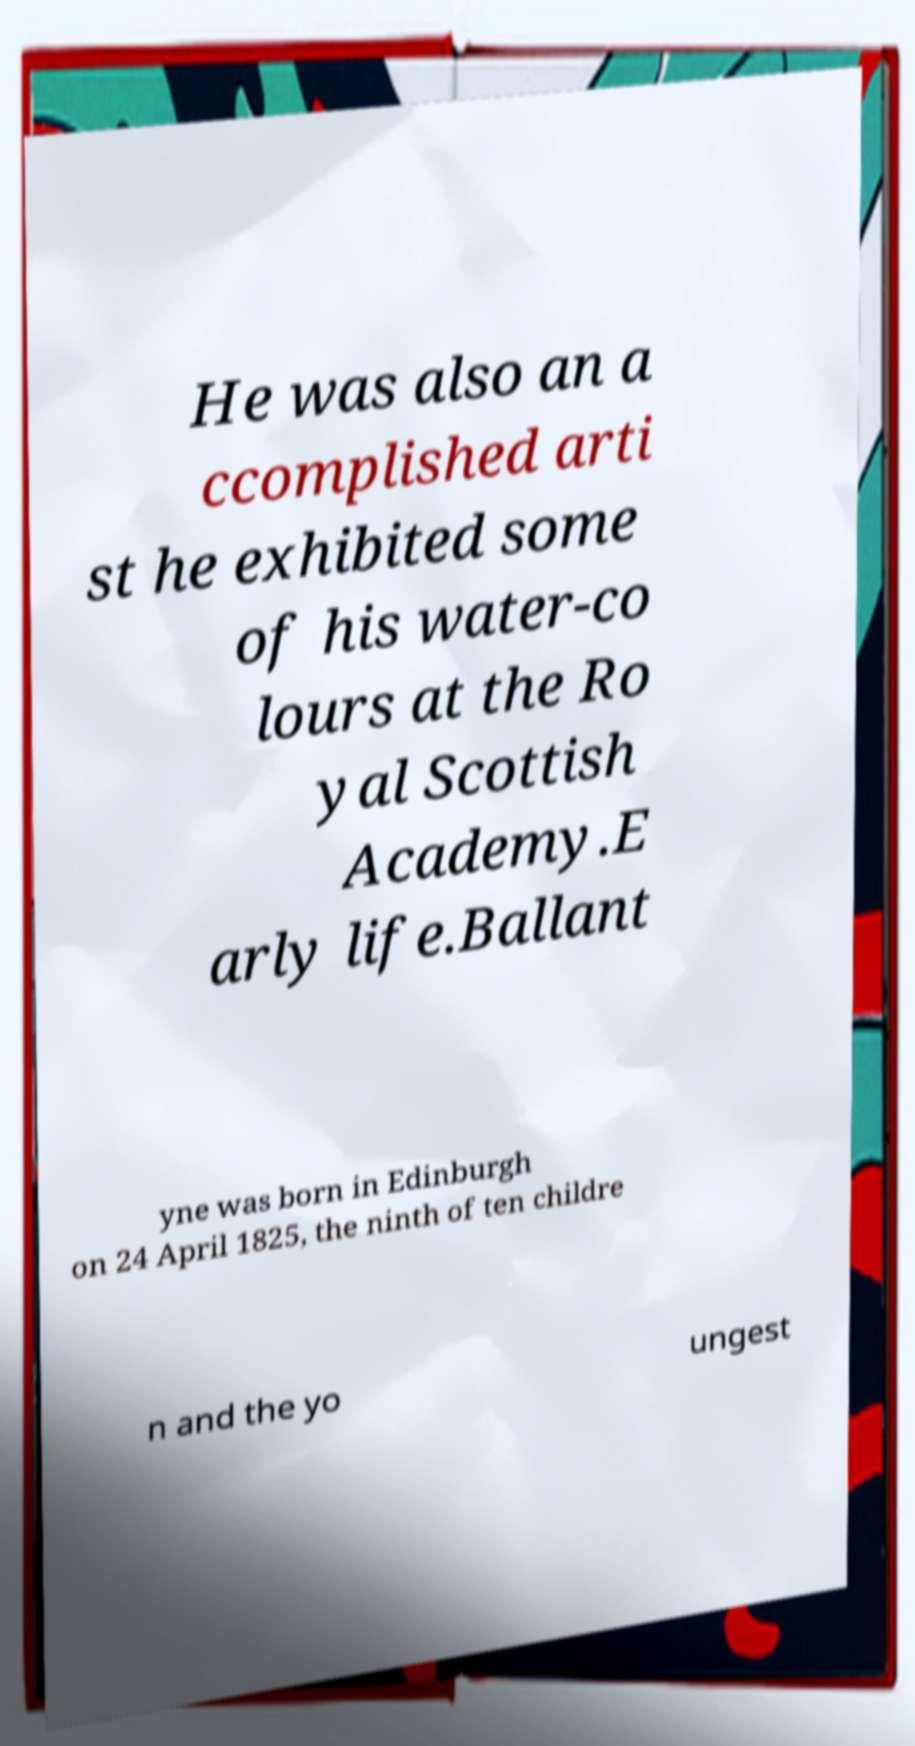Please read and relay the text visible in this image. What does it say? He was also an a ccomplished arti st he exhibited some of his water-co lours at the Ro yal Scottish Academy.E arly life.Ballant yne was born in Edinburgh on 24 April 1825, the ninth of ten childre n and the yo ungest 